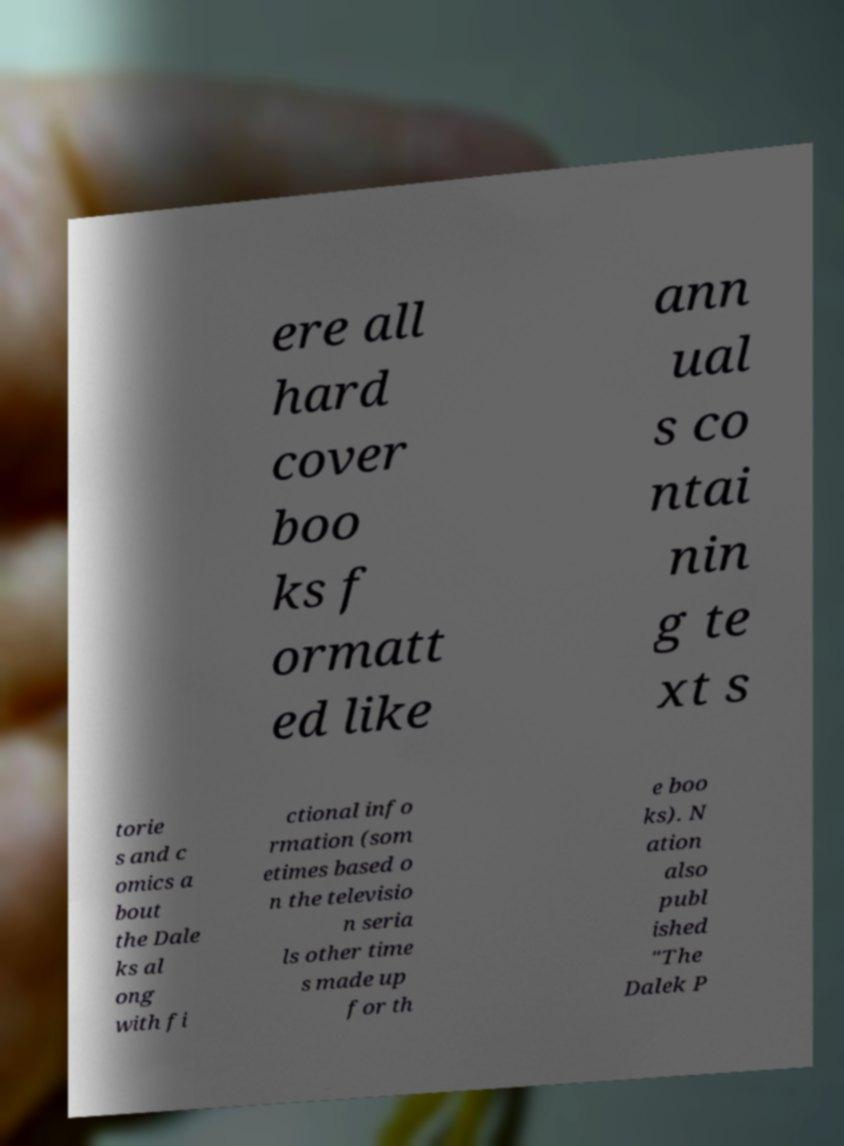Can you accurately transcribe the text from the provided image for me? ere all hard cover boo ks f ormatt ed like ann ual s co ntai nin g te xt s torie s and c omics a bout the Dale ks al ong with fi ctional info rmation (som etimes based o n the televisio n seria ls other time s made up for th e boo ks). N ation also publ ished "The Dalek P 